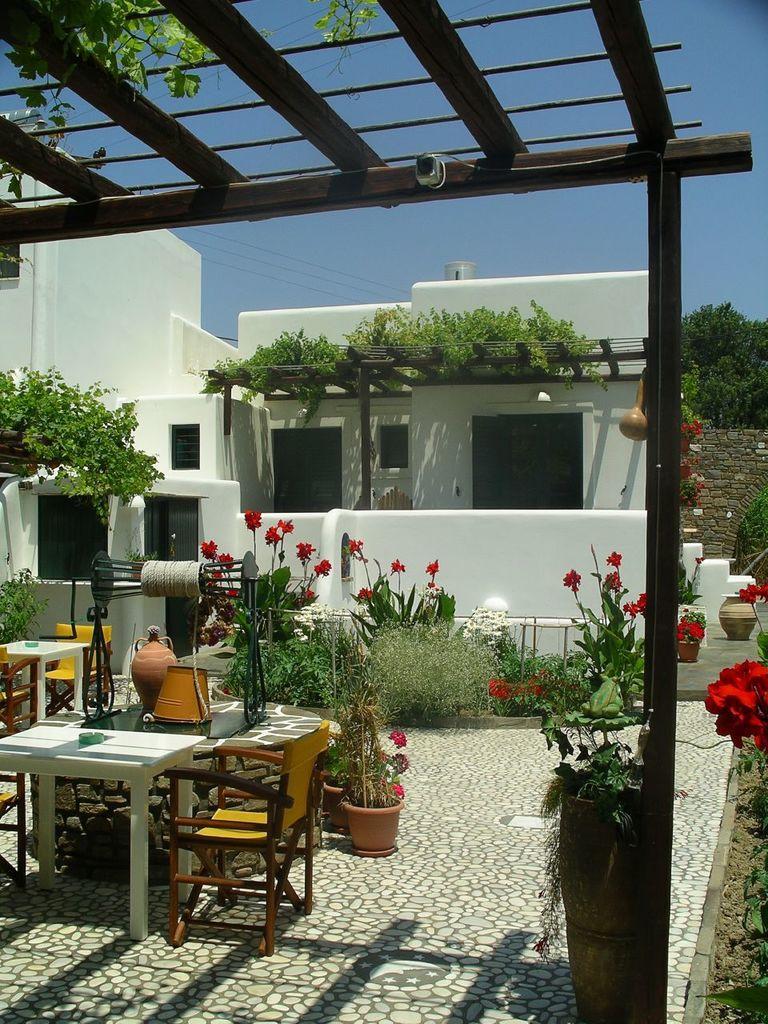In one or two sentences, can you explain what this image depicts? In this image there is a table and chair at the left side of image and there is a well beside it. Bucket and pot are in it. There are few pots, plants at the middle of image. Backside there is a house. Right side there is a flower. There is a wall behind there is a tree. Sky is at top of image. 